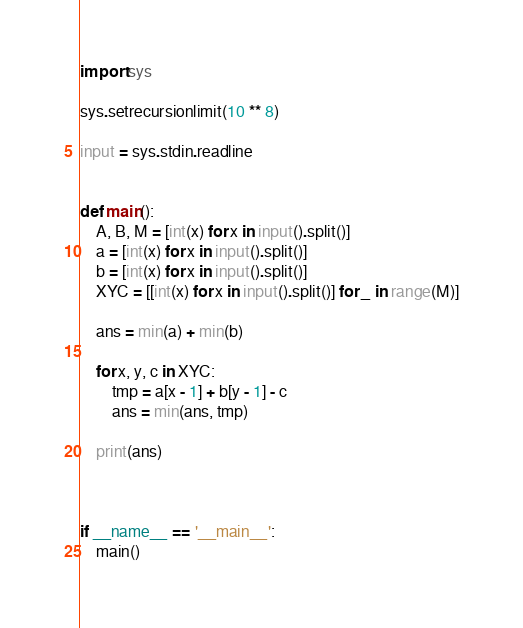<code> <loc_0><loc_0><loc_500><loc_500><_Python_>import sys

sys.setrecursionlimit(10 ** 8)

input = sys.stdin.readline


def main():
    A, B, M = [int(x) for x in input().split()]
    a = [int(x) for x in input().split()]
    b = [int(x) for x in input().split()]
    XYC = [[int(x) for x in input().split()] for _ in range(M)]

    ans = min(a) + min(b)

    for x, y, c in XYC:
        tmp = a[x - 1] + b[y - 1] - c
        ans = min(ans, tmp)

    print(ans)



if __name__ == '__main__':
    main()
</code> 